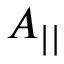Convert formula to latex. <formula><loc_0><loc_0><loc_500><loc_500>A _ { | | }</formula> 